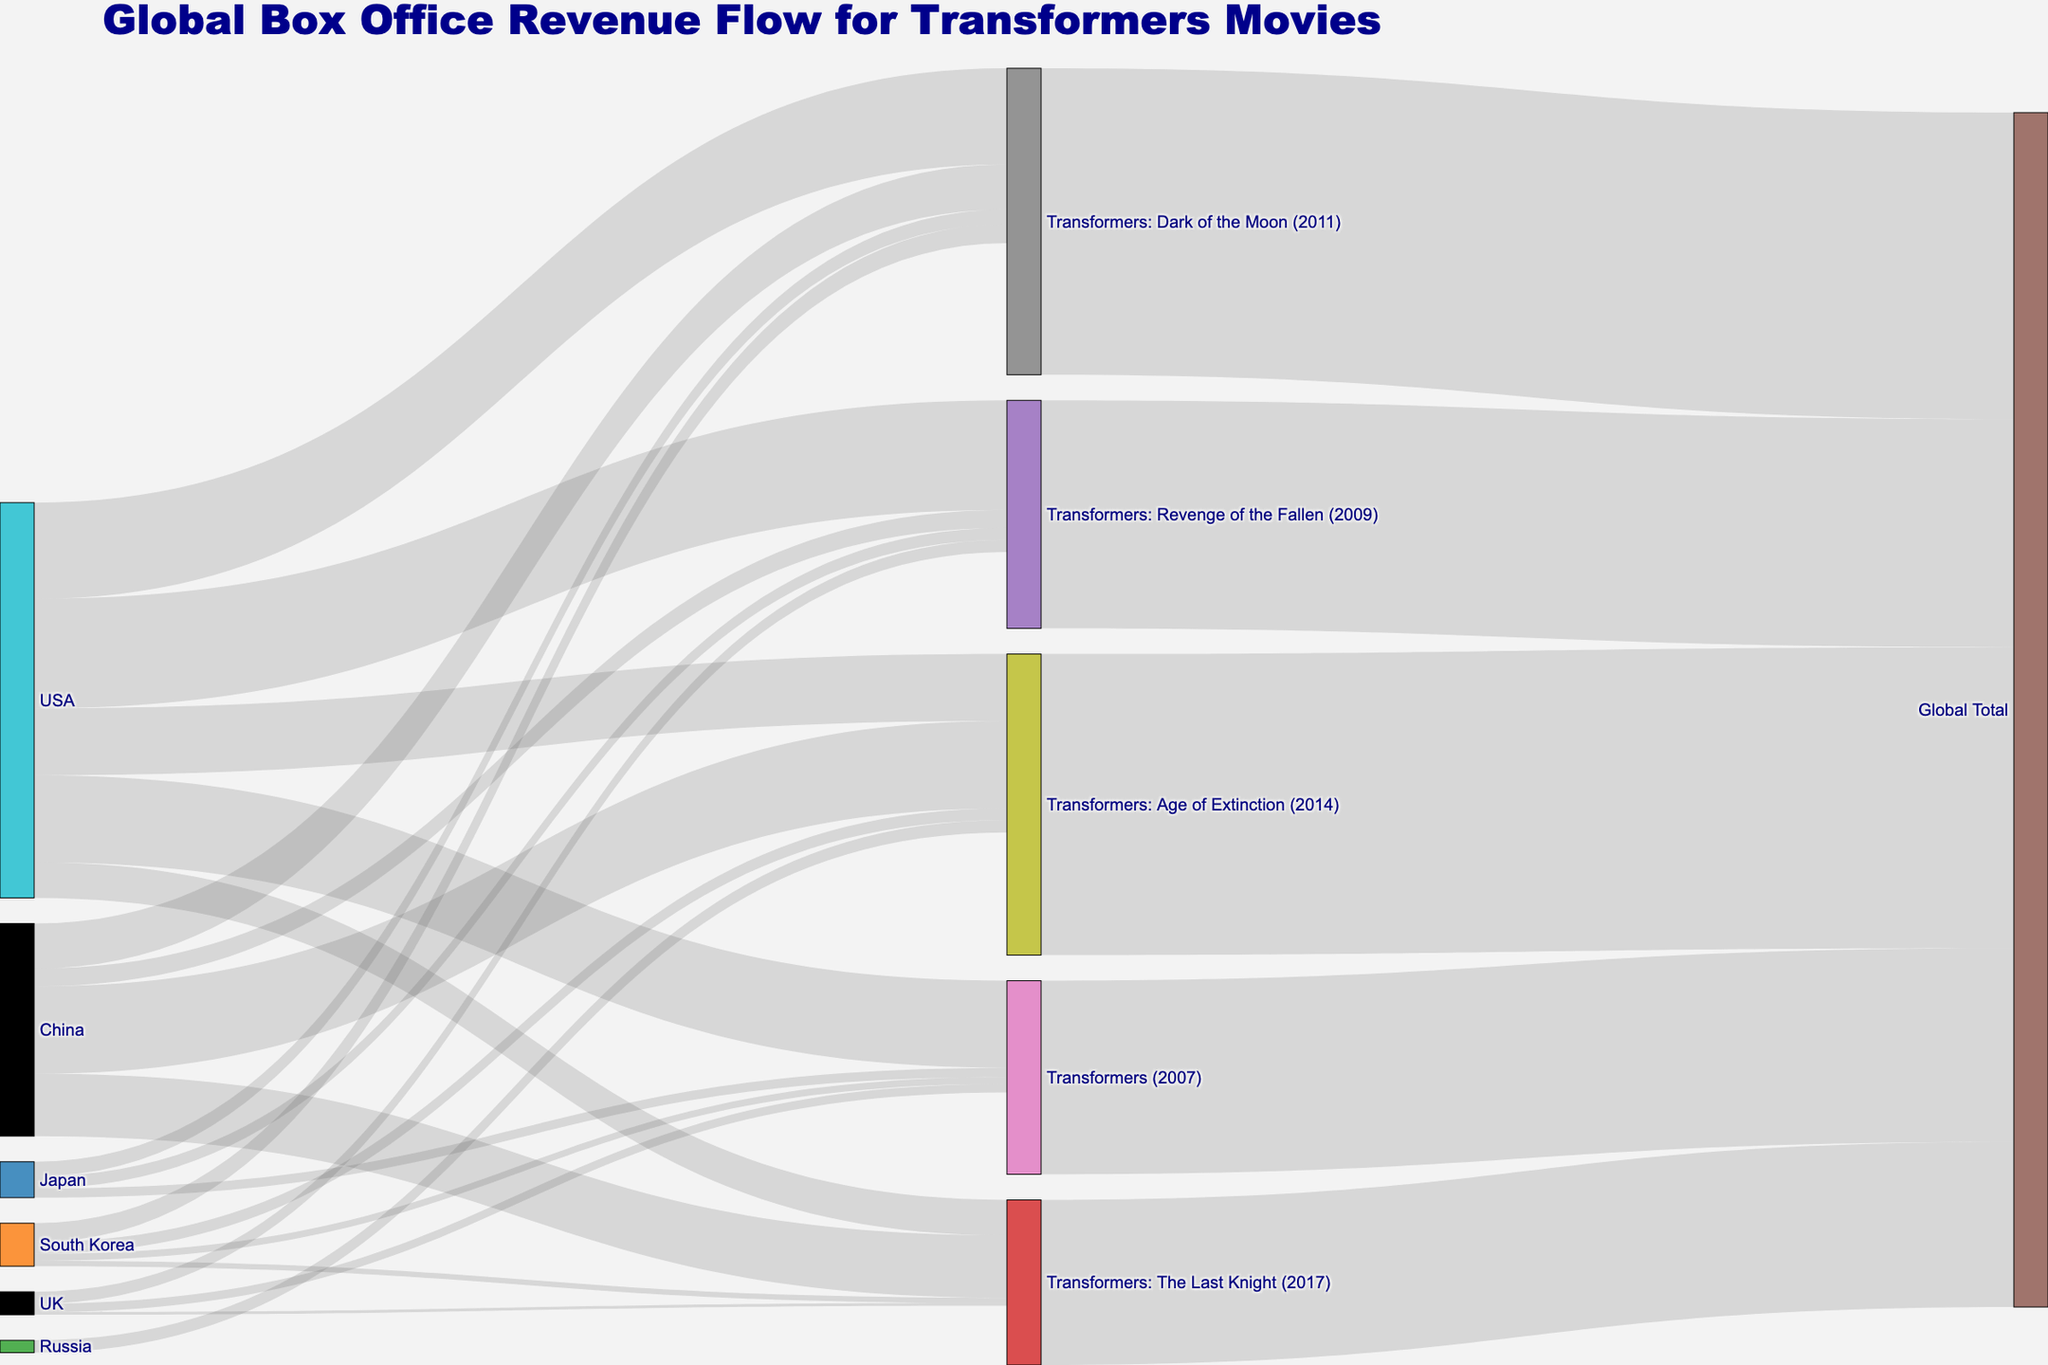What is the title of the diagram? The title of the diagram is located at the top and gives a clear indication of the overall content. It helps to understand the main focus of the diagram.
Answer: Global Box Office Revenue Flow for Transformers Movies How many countries are included in the diagram? To find the number of countries, count the unique country names listed as sources on the left side of the diagram.
Answer: 6 Which Transformers movie has the highest global total revenue? Compare the global total revenues mentioned for each Transformers movie in the nodes connected to "Global Total." The movie with the highest value has the highest global total revenue.
Answer: Transformers: Dark of the Moon (2011) How much revenue did "Transformers: The Last Knight (2017)" generate from China? Track the flow connecting "China" to "Transformers: The Last Knight (2017)" and read the value mentioned there.
Answer: 228842508 What is the total revenue generated in South Korea for all Transformers movies combined? Sum up the revenue values from South Korea for each Transformers movie. The values are: 25651786 + 69140655 + 43450897 + 19186891.
Answer: 157030229 Which country contributed the least to "Transformers: The Last Knight (2017)"? Compare the revenue values flowing to "Transformers: The Last Knight (2017)" from each country. The country with the smallest revenue value is the one that contributed the least.
Answer: UK By how much did the revenue from China increase from "Transformers: Revenge of the Fallen (2009)" to "Transformers: Dark of the Moon (2011)"? Find the difference between the revenue values from China for both movies. The values are 165137499 - 65834803.
Answer: 99202796 Which movie had the largest revenue difference between USA and China? For each movie, calculate the absolute difference between the revenue values from USA and China, then identify the movie with the largest difference.
Answer: Transformers: Revenge of the Fallen (2009) What is the average revenue generated by the United Kingdom for all the Transformers movies? Sum up the revenue values from the United Kingdom for each Transformers movie, and then divide by the number of movies that have UK revenue listed. The values are: 30738269 + 43929979 + 9514478 / 3.
Answer: 28194242 How does the global total revenue of "Transformers: Age of Extinction (2014)" compare to "Transformers: The Last Knight (2017)"? Compare the global total revenue values of the two movies. Identify which one is higher and by how much.
Answer: Transformers: Age of Extinction (2014) is higher by 498629915 